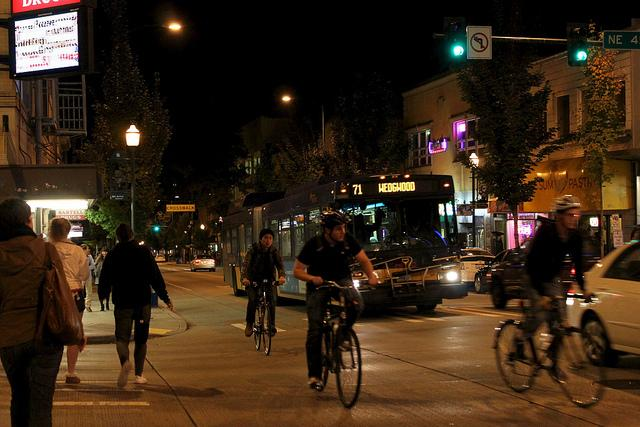What does the sign beside the green light forbid? left turn 